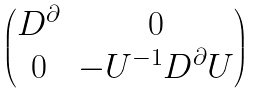Convert formula to latex. <formula><loc_0><loc_0><loc_500><loc_500>\begin{pmatrix} D ^ { \partial } & 0 \\ 0 & - U ^ { - 1 } D ^ { \partial } U \end{pmatrix}</formula> 